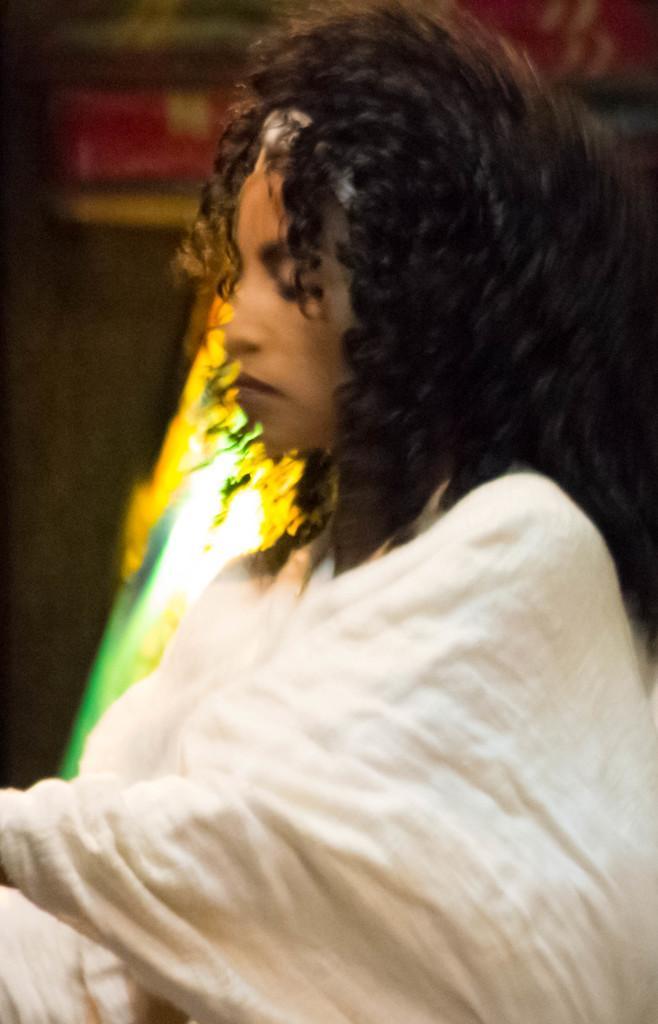Can you describe this image briefly? In this image we can see a woman. In the back there is light and it is looking blur. 